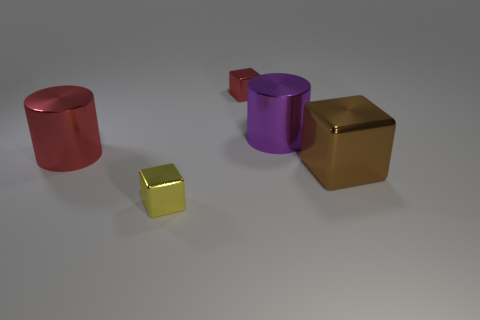What could be the purpose of these objects being placed together in this arrangement? This arrangement could be part of a visual composition to study material properties, reflections, and lighting in a 3D environment. It may also serve an aesthetic purpose, creating a visually appealing balance of shapes and colors. 